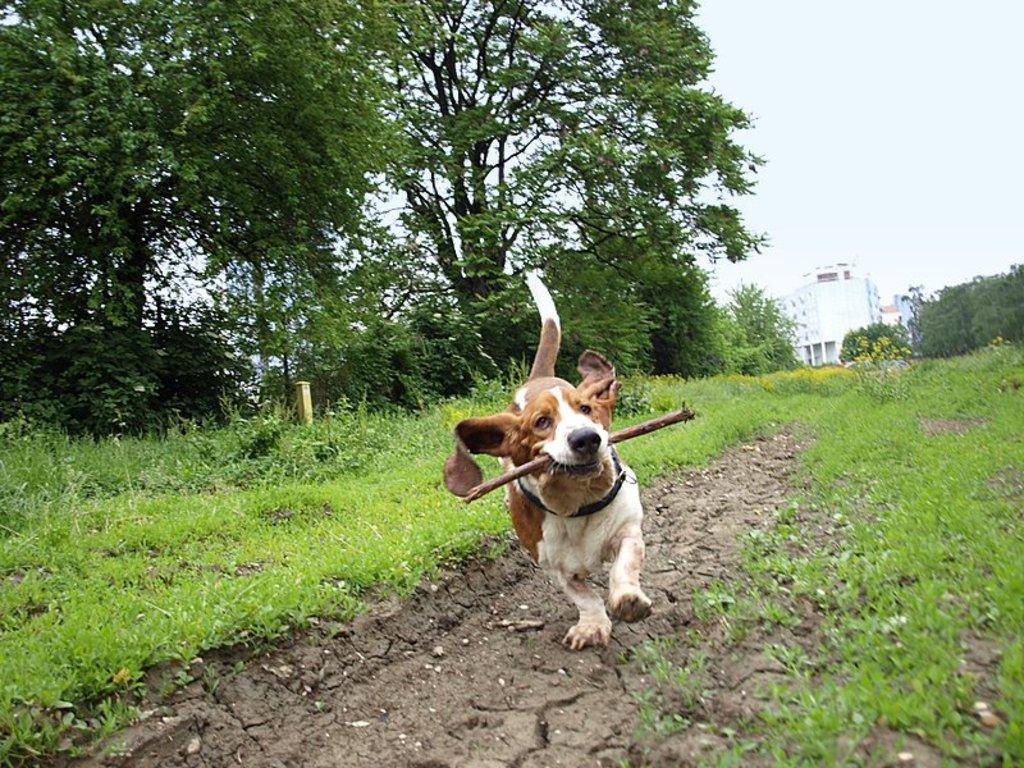What animal can be seen in the image? There is a dog in the image. What is the dog holding in the image? The dog is holding a stick. What type of vegetation is present in the image? There are trees, plants, and grass in the image. What can be seen in the background of the image? There is a building and the sky visible in the background of the image. Where is the cactus located in the image? There is no cactus present in the image. What type of bike can be seen in the image? There is no bike present in the image. 